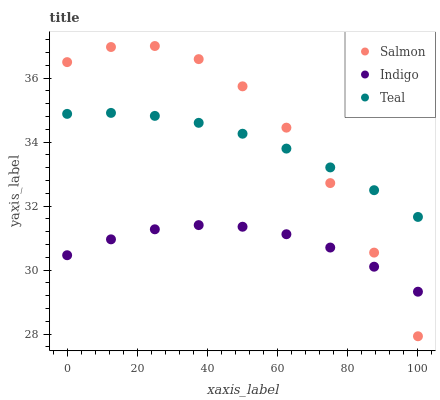Does Indigo have the minimum area under the curve?
Answer yes or no. Yes. Does Salmon have the maximum area under the curve?
Answer yes or no. Yes. Does Teal have the minimum area under the curve?
Answer yes or no. No. Does Teal have the maximum area under the curve?
Answer yes or no. No. Is Teal the smoothest?
Answer yes or no. Yes. Is Salmon the roughest?
Answer yes or no. Yes. Is Salmon the smoothest?
Answer yes or no. No. Is Teal the roughest?
Answer yes or no. No. Does Salmon have the lowest value?
Answer yes or no. Yes. Does Teal have the lowest value?
Answer yes or no. No. Does Salmon have the highest value?
Answer yes or no. Yes. Does Teal have the highest value?
Answer yes or no. No. Is Indigo less than Teal?
Answer yes or no. Yes. Is Teal greater than Indigo?
Answer yes or no. Yes. Does Teal intersect Salmon?
Answer yes or no. Yes. Is Teal less than Salmon?
Answer yes or no. No. Is Teal greater than Salmon?
Answer yes or no. No. Does Indigo intersect Teal?
Answer yes or no. No. 